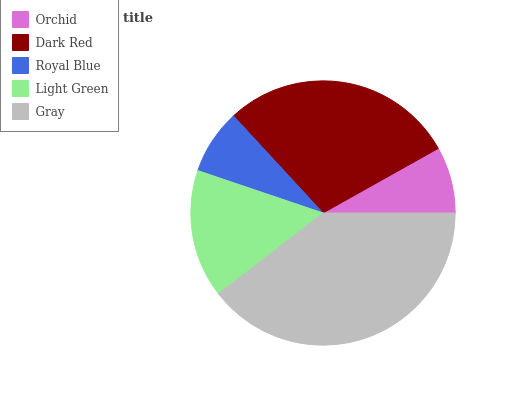Is Royal Blue the minimum?
Answer yes or no. Yes. Is Gray the maximum?
Answer yes or no. Yes. Is Dark Red the minimum?
Answer yes or no. No. Is Dark Red the maximum?
Answer yes or no. No. Is Dark Red greater than Orchid?
Answer yes or no. Yes. Is Orchid less than Dark Red?
Answer yes or no. Yes. Is Orchid greater than Dark Red?
Answer yes or no. No. Is Dark Red less than Orchid?
Answer yes or no. No. Is Light Green the high median?
Answer yes or no. Yes. Is Light Green the low median?
Answer yes or no. Yes. Is Dark Red the high median?
Answer yes or no. No. Is Orchid the low median?
Answer yes or no. No. 